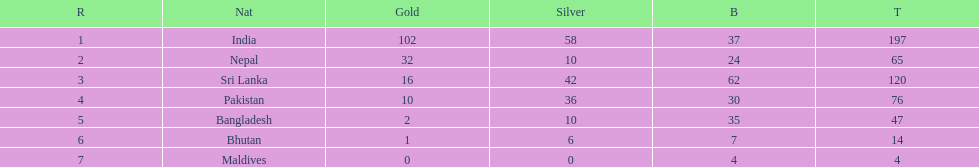What are the total number of bronze medals sri lanka have earned? 62. 